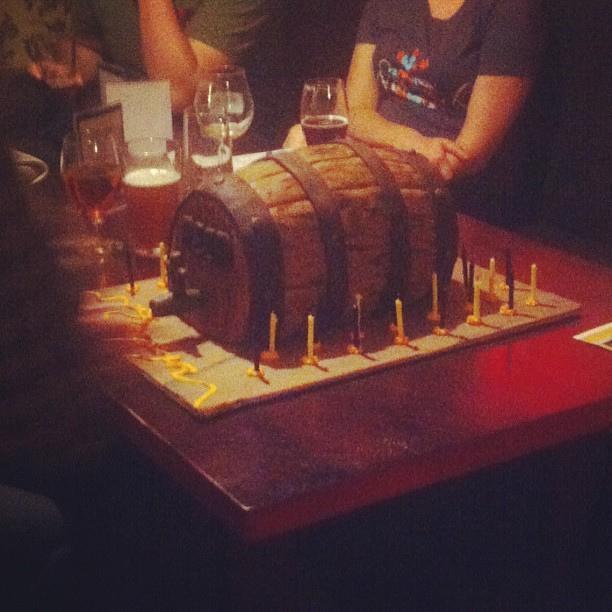How many people are there?
Give a very brief answer. 2. How many dining tables can you see?
Give a very brief answer. 1. How many wine glasses can you see?
Give a very brief answer. 5. 